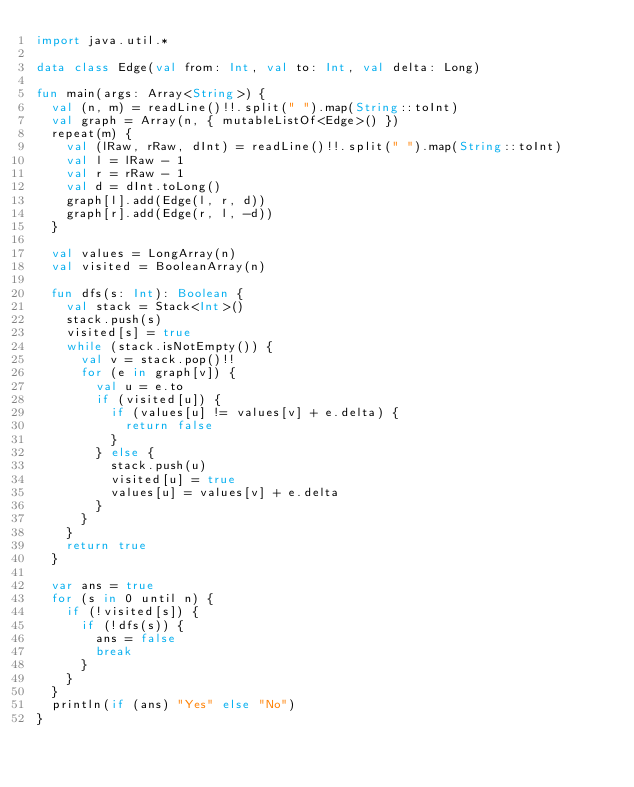<code> <loc_0><loc_0><loc_500><loc_500><_Kotlin_>import java.util.*

data class Edge(val from: Int, val to: Int, val delta: Long)

fun main(args: Array<String>) {
  val (n, m) = readLine()!!.split(" ").map(String::toInt)
  val graph = Array(n, { mutableListOf<Edge>() })
  repeat(m) {
    val (lRaw, rRaw, dInt) = readLine()!!.split(" ").map(String::toInt)
    val l = lRaw - 1
    val r = rRaw - 1
    val d = dInt.toLong()
    graph[l].add(Edge(l, r, d))
    graph[r].add(Edge(r, l, -d))
  }

  val values = LongArray(n)
  val visited = BooleanArray(n)

  fun dfs(s: Int): Boolean {
    val stack = Stack<Int>()
    stack.push(s)
    visited[s] = true
    while (stack.isNotEmpty()) {
      val v = stack.pop()!!
      for (e in graph[v]) {
        val u = e.to
        if (visited[u]) {
          if (values[u] != values[v] + e.delta) {
            return false
          }
        } else {
          stack.push(u)
          visited[u] = true
          values[u] = values[v] + e.delta
        }
      }
    }
    return true
  }

  var ans = true
  for (s in 0 until n) {
    if (!visited[s]) {
      if (!dfs(s)) {
        ans = false
        break
      }
    }
  }
  println(if (ans) "Yes" else "No")
}
</code> 